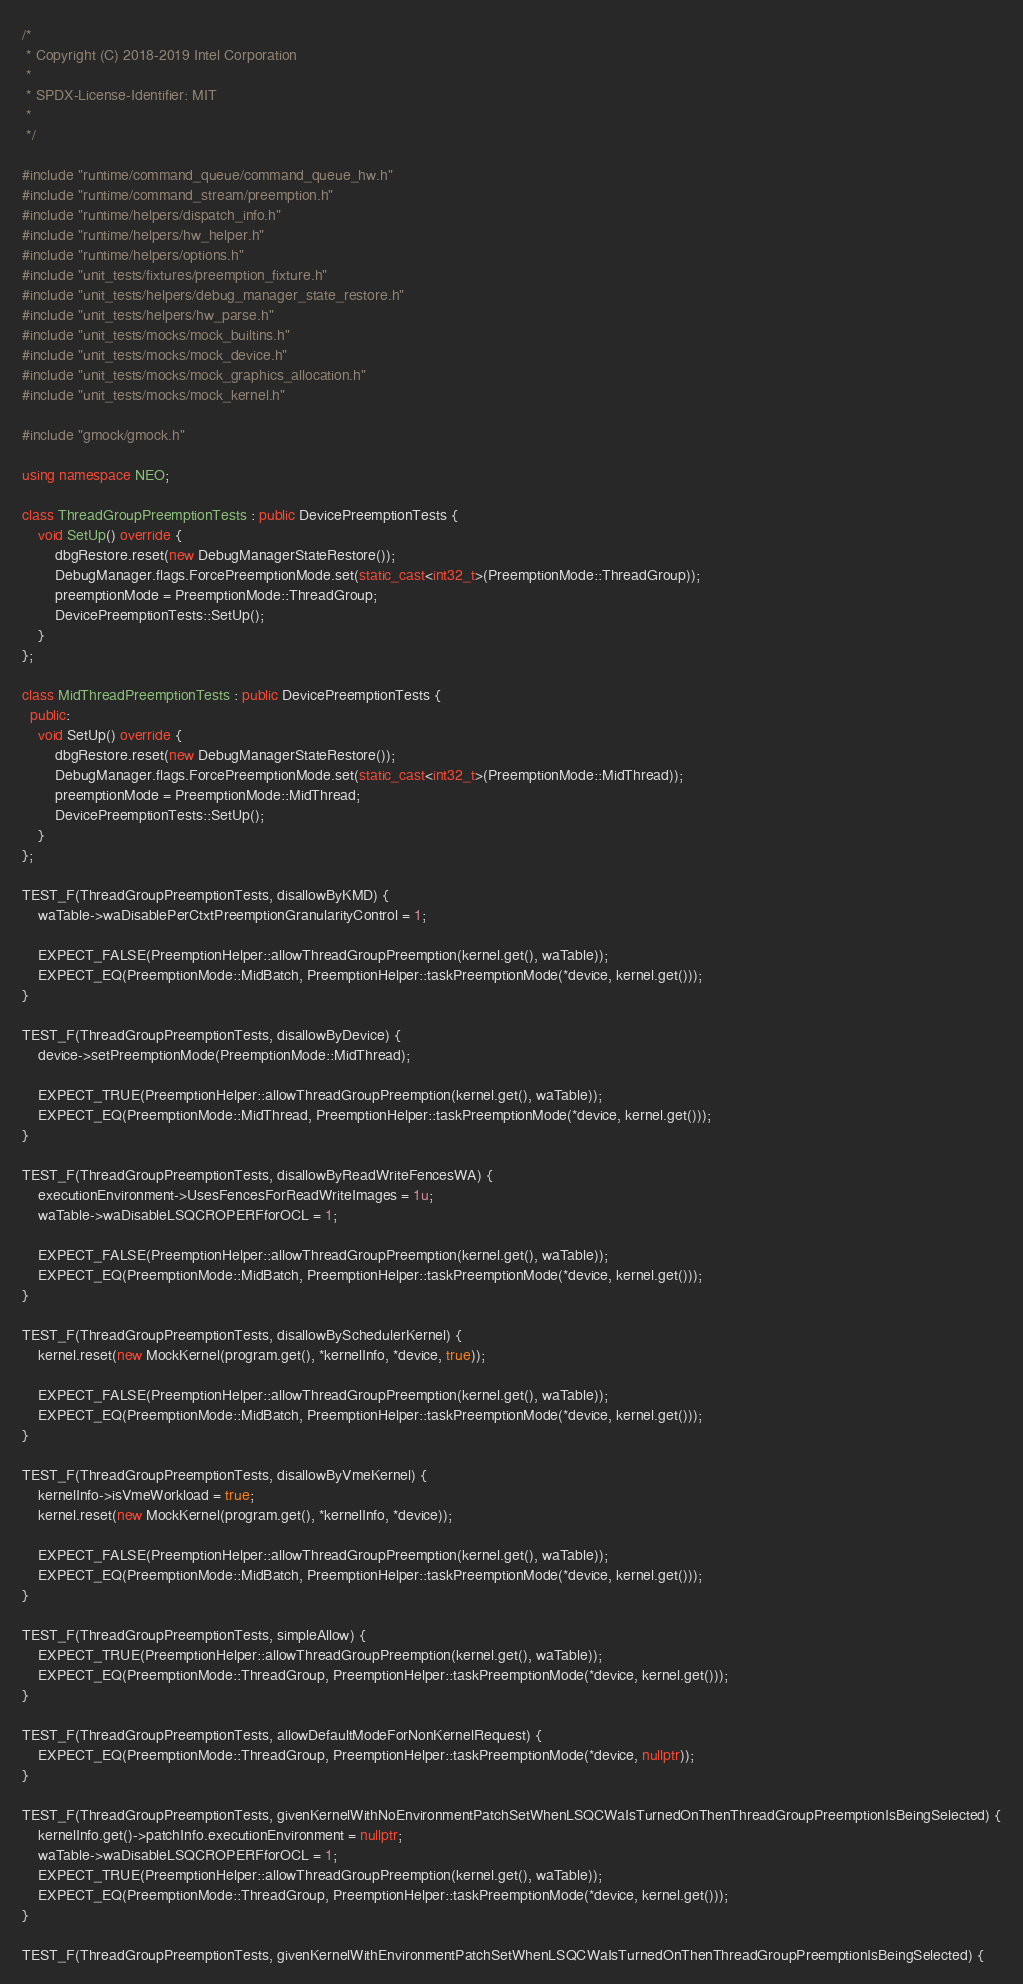<code> <loc_0><loc_0><loc_500><loc_500><_C++_>/*
 * Copyright (C) 2018-2019 Intel Corporation
 *
 * SPDX-License-Identifier: MIT
 *
 */

#include "runtime/command_queue/command_queue_hw.h"
#include "runtime/command_stream/preemption.h"
#include "runtime/helpers/dispatch_info.h"
#include "runtime/helpers/hw_helper.h"
#include "runtime/helpers/options.h"
#include "unit_tests/fixtures/preemption_fixture.h"
#include "unit_tests/helpers/debug_manager_state_restore.h"
#include "unit_tests/helpers/hw_parse.h"
#include "unit_tests/mocks/mock_builtins.h"
#include "unit_tests/mocks/mock_device.h"
#include "unit_tests/mocks/mock_graphics_allocation.h"
#include "unit_tests/mocks/mock_kernel.h"

#include "gmock/gmock.h"

using namespace NEO;

class ThreadGroupPreemptionTests : public DevicePreemptionTests {
    void SetUp() override {
        dbgRestore.reset(new DebugManagerStateRestore());
        DebugManager.flags.ForcePreemptionMode.set(static_cast<int32_t>(PreemptionMode::ThreadGroup));
        preemptionMode = PreemptionMode::ThreadGroup;
        DevicePreemptionTests::SetUp();
    }
};

class MidThreadPreemptionTests : public DevicePreemptionTests {
  public:
    void SetUp() override {
        dbgRestore.reset(new DebugManagerStateRestore());
        DebugManager.flags.ForcePreemptionMode.set(static_cast<int32_t>(PreemptionMode::MidThread));
        preemptionMode = PreemptionMode::MidThread;
        DevicePreemptionTests::SetUp();
    }
};

TEST_F(ThreadGroupPreemptionTests, disallowByKMD) {
    waTable->waDisablePerCtxtPreemptionGranularityControl = 1;

    EXPECT_FALSE(PreemptionHelper::allowThreadGroupPreemption(kernel.get(), waTable));
    EXPECT_EQ(PreemptionMode::MidBatch, PreemptionHelper::taskPreemptionMode(*device, kernel.get()));
}

TEST_F(ThreadGroupPreemptionTests, disallowByDevice) {
    device->setPreemptionMode(PreemptionMode::MidThread);

    EXPECT_TRUE(PreemptionHelper::allowThreadGroupPreemption(kernel.get(), waTable));
    EXPECT_EQ(PreemptionMode::MidThread, PreemptionHelper::taskPreemptionMode(*device, kernel.get()));
}

TEST_F(ThreadGroupPreemptionTests, disallowByReadWriteFencesWA) {
    executionEnvironment->UsesFencesForReadWriteImages = 1u;
    waTable->waDisableLSQCROPERFforOCL = 1;

    EXPECT_FALSE(PreemptionHelper::allowThreadGroupPreemption(kernel.get(), waTable));
    EXPECT_EQ(PreemptionMode::MidBatch, PreemptionHelper::taskPreemptionMode(*device, kernel.get()));
}

TEST_F(ThreadGroupPreemptionTests, disallowBySchedulerKernel) {
    kernel.reset(new MockKernel(program.get(), *kernelInfo, *device, true));

    EXPECT_FALSE(PreemptionHelper::allowThreadGroupPreemption(kernel.get(), waTable));
    EXPECT_EQ(PreemptionMode::MidBatch, PreemptionHelper::taskPreemptionMode(*device, kernel.get()));
}

TEST_F(ThreadGroupPreemptionTests, disallowByVmeKernel) {
    kernelInfo->isVmeWorkload = true;
    kernel.reset(new MockKernel(program.get(), *kernelInfo, *device));

    EXPECT_FALSE(PreemptionHelper::allowThreadGroupPreemption(kernel.get(), waTable));
    EXPECT_EQ(PreemptionMode::MidBatch, PreemptionHelper::taskPreemptionMode(*device, kernel.get()));
}

TEST_F(ThreadGroupPreemptionTests, simpleAllow) {
    EXPECT_TRUE(PreemptionHelper::allowThreadGroupPreemption(kernel.get(), waTable));
    EXPECT_EQ(PreemptionMode::ThreadGroup, PreemptionHelper::taskPreemptionMode(*device, kernel.get()));
}

TEST_F(ThreadGroupPreemptionTests, allowDefaultModeForNonKernelRequest) {
    EXPECT_EQ(PreemptionMode::ThreadGroup, PreemptionHelper::taskPreemptionMode(*device, nullptr));
}

TEST_F(ThreadGroupPreemptionTests, givenKernelWithNoEnvironmentPatchSetWhenLSQCWaIsTurnedOnThenThreadGroupPreemptionIsBeingSelected) {
    kernelInfo.get()->patchInfo.executionEnvironment = nullptr;
    waTable->waDisableLSQCROPERFforOCL = 1;
    EXPECT_TRUE(PreemptionHelper::allowThreadGroupPreemption(kernel.get(), waTable));
    EXPECT_EQ(PreemptionMode::ThreadGroup, PreemptionHelper::taskPreemptionMode(*device, kernel.get()));
}

TEST_F(ThreadGroupPreemptionTests, givenKernelWithEnvironmentPatchSetWhenLSQCWaIsTurnedOnThenThreadGroupPreemptionIsBeingSelected) {</code> 